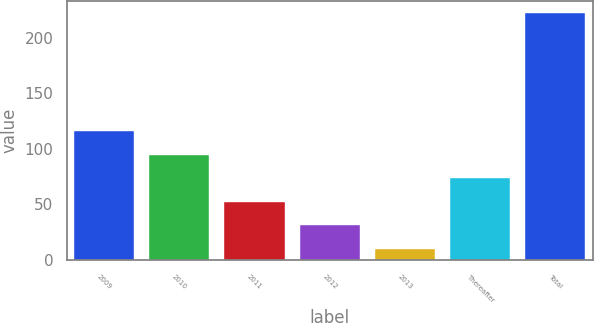Convert chart. <chart><loc_0><loc_0><loc_500><loc_500><bar_chart><fcel>2009<fcel>2010<fcel>2011<fcel>2012<fcel>2013<fcel>Thereafter<fcel>Total<nl><fcel>116<fcel>94.8<fcel>52.4<fcel>31.2<fcel>10<fcel>73.6<fcel>222<nl></chart> 